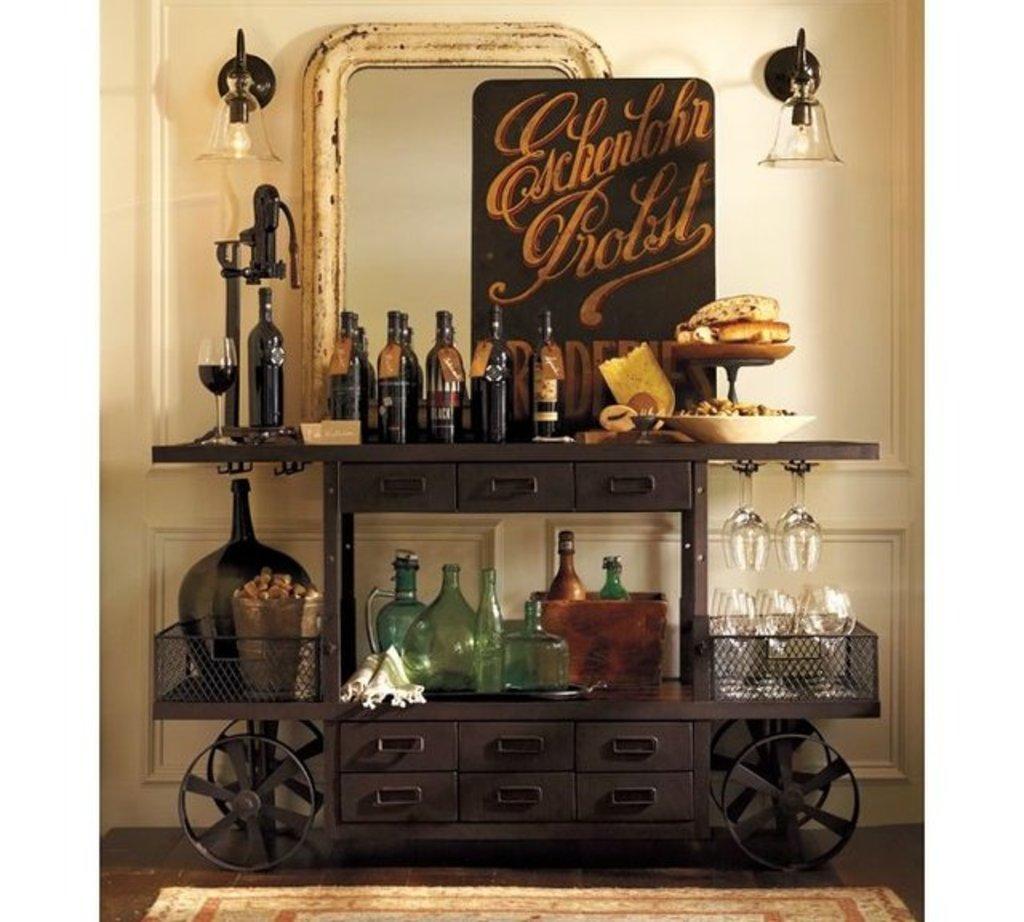What's written on the board above the bar?
Provide a succinct answer. Eschenlohr brolst. 